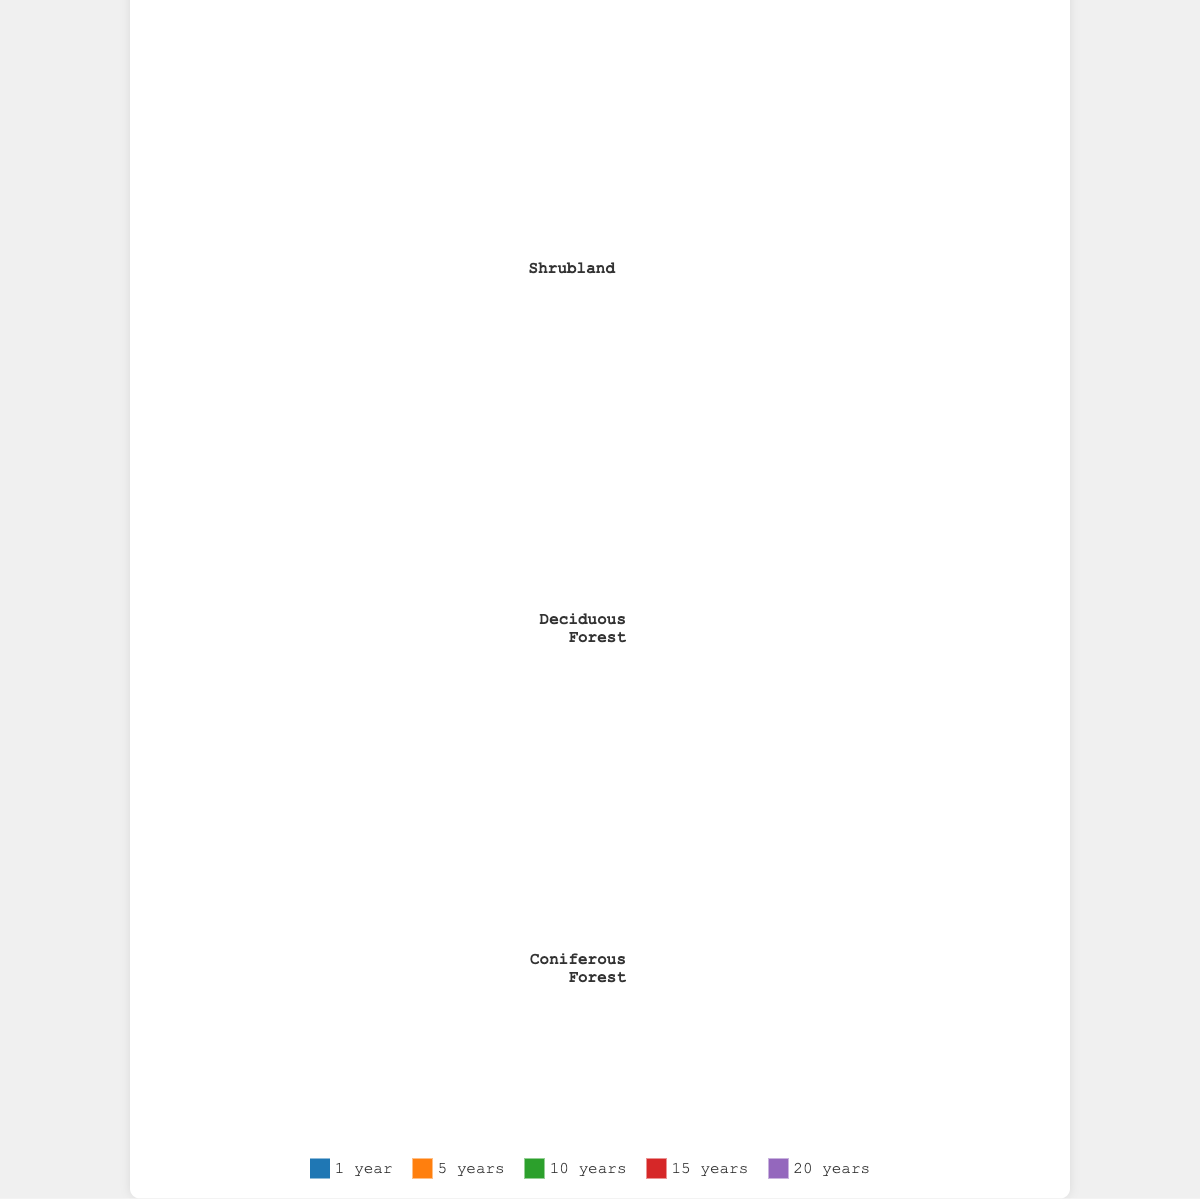How many years have passed in the dataset? The horizontal axis represents the years since clearance, and we see labels for each distinct year.
Answer: 5 Which vegetation type shows the fastest initial recovery rate after 1 year? By looking at the icons under the 1 year column, we see Grassland has the most icons, indicating the fastest recovery at 10%.
Answer: Grassland Which vegetation type has the lowest recovery rate in the first 5 years? By comparing the icons under the 5 years column, we find that Coniferous Forest has the fewest icons with a 10% recovery rate.
Answer: Coniferous Forest What is the total recovery rate of Shrubland after 20 years? We look at the last column for Shrubland, which shows the rate as 90%.
Answer: 90% How do the recovery rates of Deciduous Forest and Grassland compare after 10 years? By examining the two rows for Grassland and Deciduous Forest under the 10 years column, Grassland has more icons (70%) compared to Deciduous Forest (40%).
Answer: Grassland is higher What is the average recovery rate for Coniferous Forest over 20 years? The recovery rates for Coniferous Forest are [1, 10, 35, 60, 80]. Adding them up, we get 1+10+35+60+80=186. Dividing by the number of years (5), we get an average of 186/5=37.2%.
Answer: 37.2% Which two vegetation types have the closest recovery rates at the 15-year mark? By comparing the number of icons in the 15-year column, Deciduous Forest (65%) and Coniferous Forest (60%) have the closest values.
Answer: Deciduous Forest and Coniferous Forest Which vegetation type shows the least improvement in recovery rate after 10 years compared to 5 years? The difference in recovery rate for each type between 10 years and 5 years is calculated: 
Grassland: 70-45=25, 
Shrubland: 60-30=30,
Deciduous Forest: 40-15=25, 
Coniferous Forest: 35-10=25.
The least improvement is seen in Deciduous Forest and Coniferous Forest with a difference of 25%.
Answer: Deciduous Forest and Coniferous Forest Which vegetation type reaches a 95% recovery rate first and in which year? Looking at the icons for a 95% recovery rate, Grassland reaches this rate after 20 years.
Answer: Grassland at year 20 